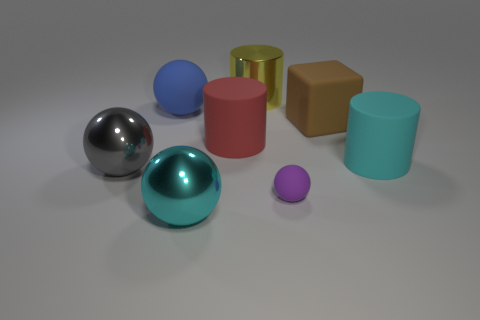Subtract all rubber cylinders. How many cylinders are left? 1 Subtract all purple balls. How many balls are left? 3 Subtract all blocks. How many objects are left? 7 Add 2 cyan metal spheres. How many objects exist? 10 Subtract 2 balls. How many balls are left? 2 Subtract all brown cylinders. Subtract all purple spheres. How many cylinders are left? 3 Subtract all purple spheres. How many yellow cylinders are left? 1 Subtract all yellow cylinders. Subtract all large red cylinders. How many objects are left? 6 Add 5 blue matte things. How many blue matte things are left? 6 Add 5 large brown blocks. How many large brown blocks exist? 6 